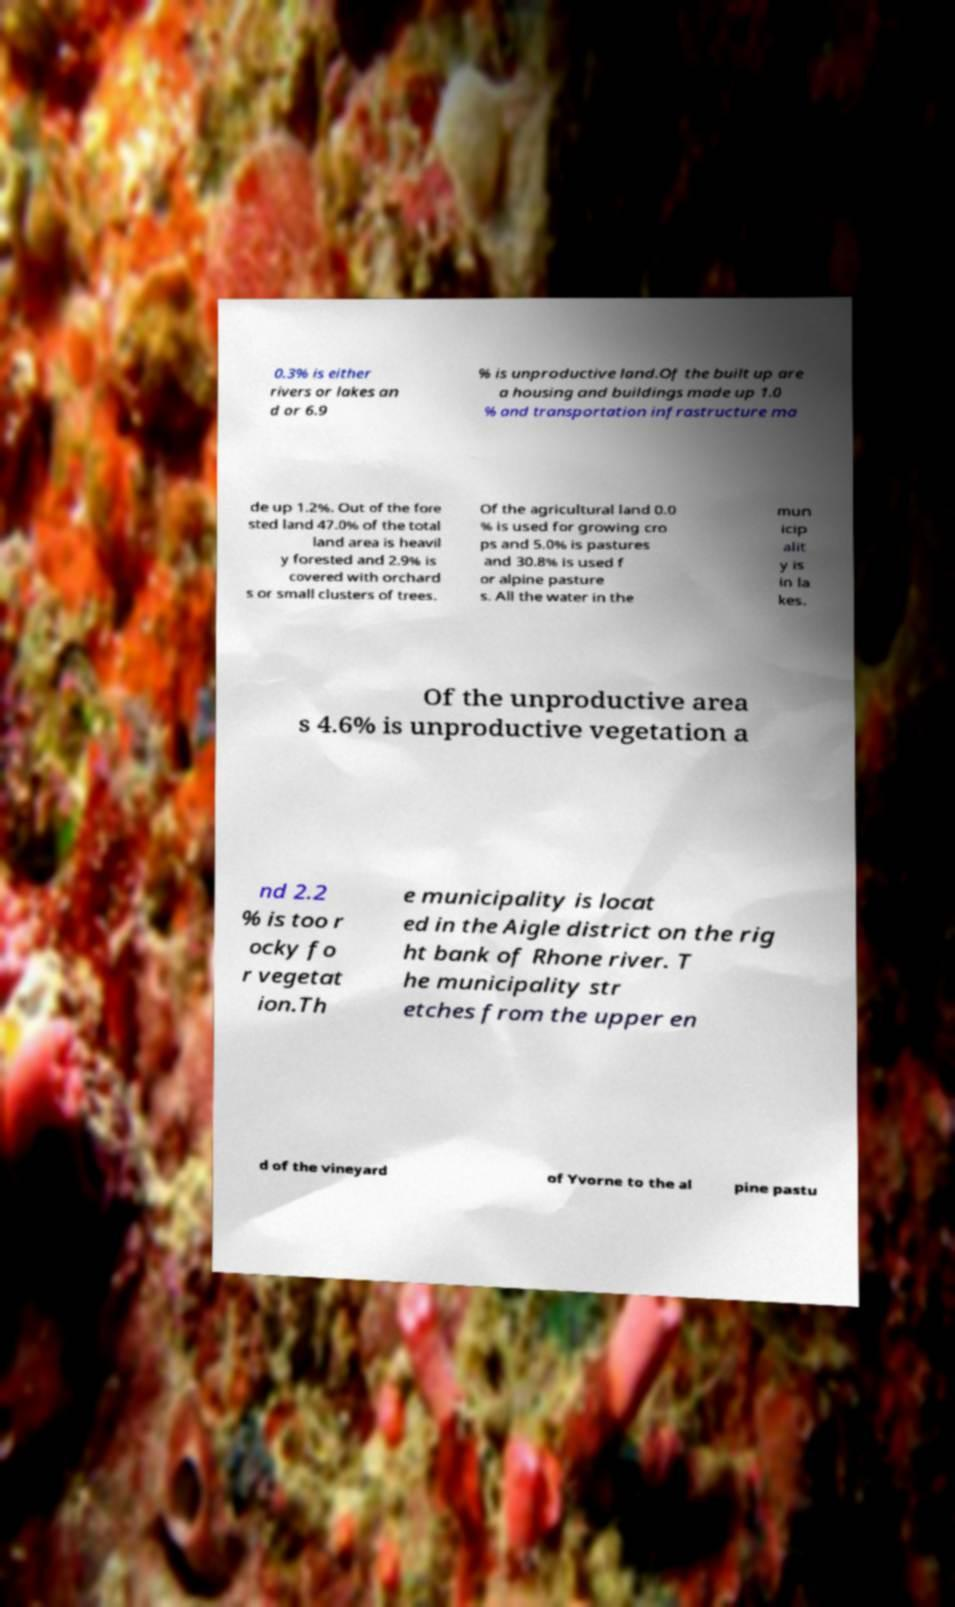There's text embedded in this image that I need extracted. Can you transcribe it verbatim? 0.3% is either rivers or lakes an d or 6.9 % is unproductive land.Of the built up are a housing and buildings made up 1.0 % and transportation infrastructure ma de up 1.2%. Out of the fore sted land 47.0% of the total land area is heavil y forested and 2.9% is covered with orchard s or small clusters of trees. Of the agricultural land 0.0 % is used for growing cro ps and 5.0% is pastures and 30.8% is used f or alpine pasture s. All the water in the mun icip alit y is in la kes. Of the unproductive area s 4.6% is unproductive vegetation a nd 2.2 % is too r ocky fo r vegetat ion.Th e municipality is locat ed in the Aigle district on the rig ht bank of Rhone river. T he municipality str etches from the upper en d of the vineyard of Yvorne to the al pine pastu 